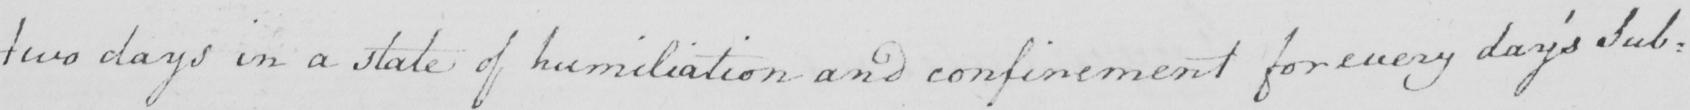What does this handwritten line say? two days in a state of humiliation and confinement for every day ' s Sub= 